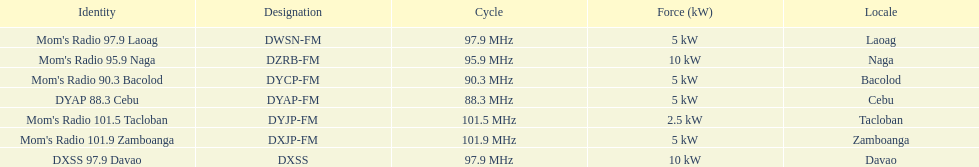How many stations have at least 5 kw or more listed in the power column? 6. 